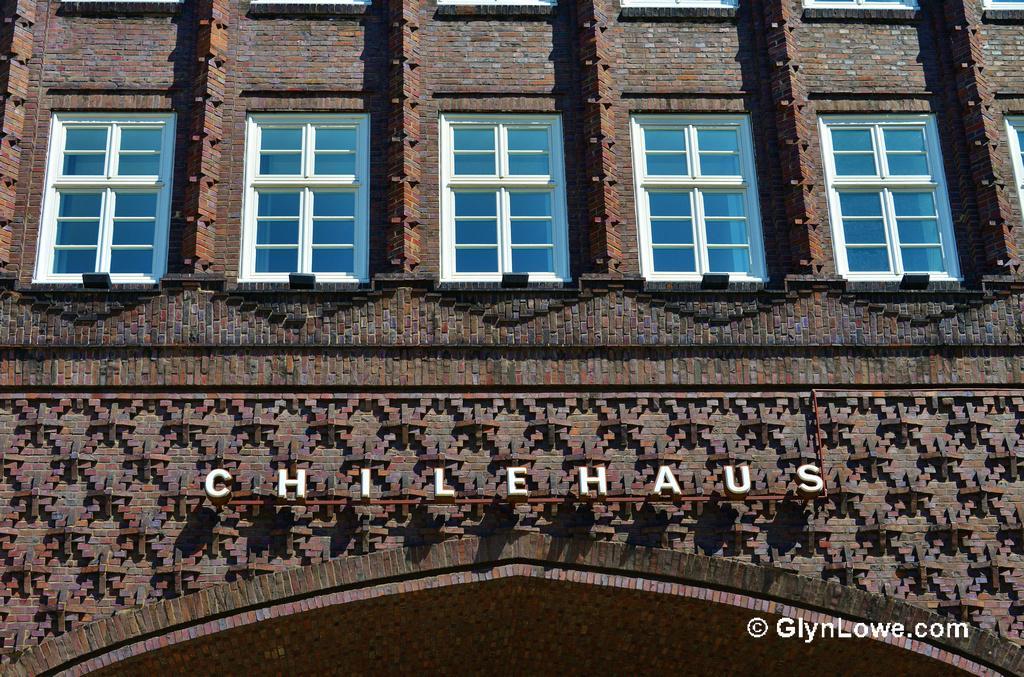Please provide a concise description of this image. The picture consists of a building. In the picture we can see windows, text and brick wall. 